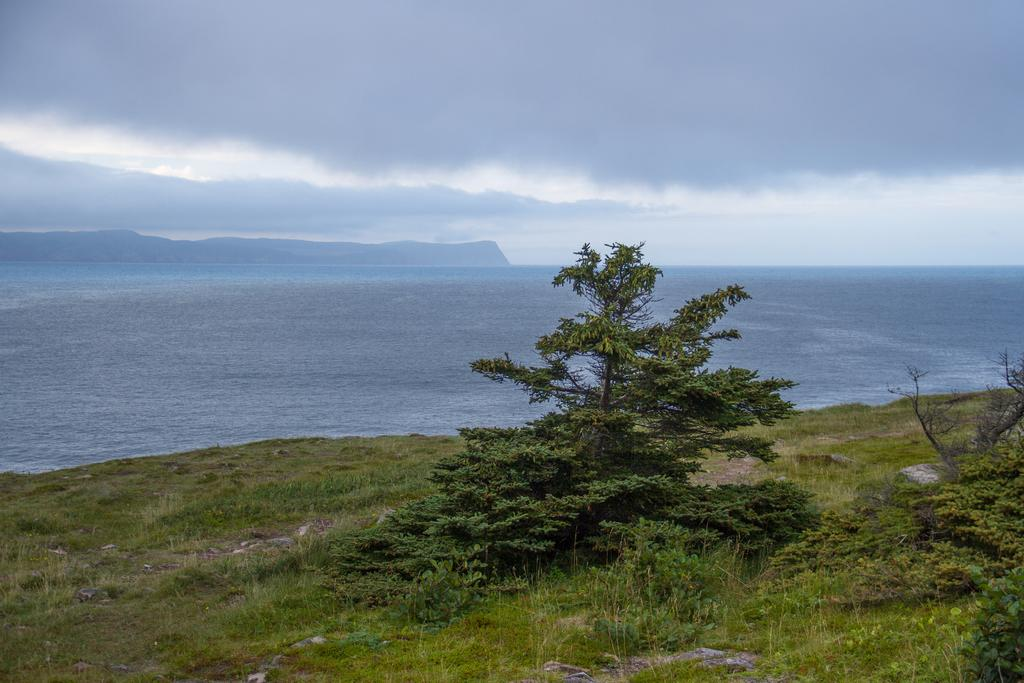What type of vegetation is present in the image? There is grass and trees in the image. What natural feature can be seen in the image? There is water visible in the image. What type of terrain is depicted in the image? There are hills in the image. What is the condition of the sky in the background? The sky in the background is cloudy. How many pizzas are being served to the beggar in the image? There are no pizzas or beggars present in the image. What is the wealth status of the person in the image? There is no information about the wealth status of any person in the image. 